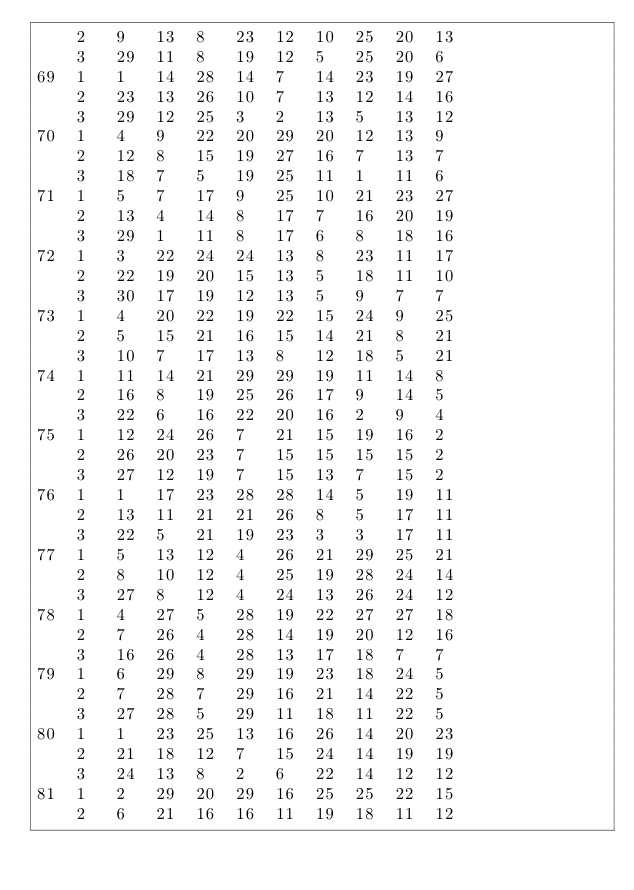<code> <loc_0><loc_0><loc_500><loc_500><_ObjectiveC_>	2	9	13	8	23	12	10	25	20	13	
	3	29	11	8	19	12	5	25	20	6	
69	1	1	14	28	14	7	14	23	19	27	
	2	23	13	26	10	7	13	12	14	16	
	3	29	12	25	3	2	13	5	13	12	
70	1	4	9	22	20	29	20	12	13	9	
	2	12	8	15	19	27	16	7	13	7	
	3	18	7	5	19	25	11	1	11	6	
71	1	5	7	17	9	25	10	21	23	27	
	2	13	4	14	8	17	7	16	20	19	
	3	29	1	11	8	17	6	8	18	16	
72	1	3	22	24	24	13	8	23	11	17	
	2	22	19	20	15	13	5	18	11	10	
	3	30	17	19	12	13	5	9	7	7	
73	1	4	20	22	19	22	15	24	9	25	
	2	5	15	21	16	15	14	21	8	21	
	3	10	7	17	13	8	12	18	5	21	
74	1	11	14	21	29	29	19	11	14	8	
	2	16	8	19	25	26	17	9	14	5	
	3	22	6	16	22	20	16	2	9	4	
75	1	12	24	26	7	21	15	19	16	2	
	2	26	20	23	7	15	15	15	15	2	
	3	27	12	19	7	15	13	7	15	2	
76	1	1	17	23	28	28	14	5	19	11	
	2	13	11	21	21	26	8	5	17	11	
	3	22	5	21	19	23	3	3	17	11	
77	1	5	13	12	4	26	21	29	25	21	
	2	8	10	12	4	25	19	28	24	14	
	3	27	8	12	4	24	13	26	24	12	
78	1	4	27	5	28	19	22	27	27	18	
	2	7	26	4	28	14	19	20	12	16	
	3	16	26	4	28	13	17	18	7	7	
79	1	6	29	8	29	19	23	18	24	5	
	2	7	28	7	29	16	21	14	22	5	
	3	27	28	5	29	11	18	11	22	5	
80	1	1	23	25	13	16	26	14	20	23	
	2	21	18	12	7	15	24	14	19	19	
	3	24	13	8	2	6	22	14	12	12	
81	1	2	29	20	29	16	25	25	22	15	
	2	6	21	16	16	11	19	18	11	12	</code> 